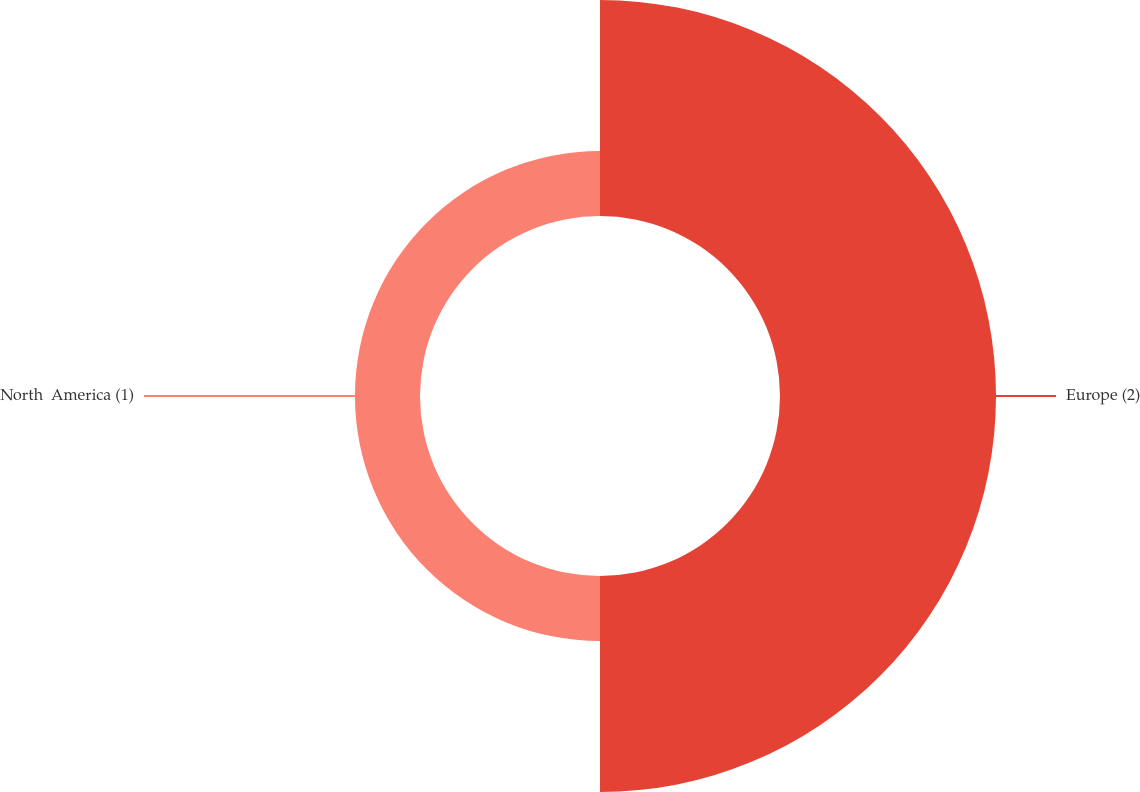Convert chart to OTSL. <chart><loc_0><loc_0><loc_500><loc_500><pie_chart><fcel>Europe (2)<fcel>North  America (1)<nl><fcel>76.86%<fcel>23.14%<nl></chart> 